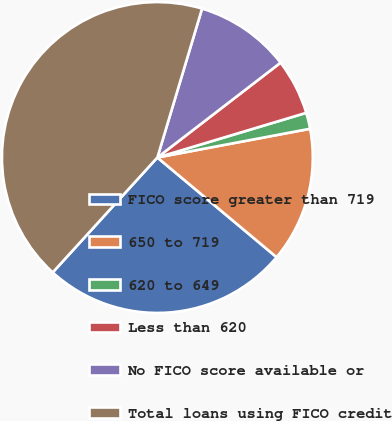Convert chart to OTSL. <chart><loc_0><loc_0><loc_500><loc_500><pie_chart><fcel>FICO score greater than 719<fcel>650 to 719<fcel>620 to 649<fcel>Less than 620<fcel>No FICO score available or<fcel>Total loans using FICO credit<nl><fcel>25.67%<fcel>14.04%<fcel>1.68%<fcel>5.8%<fcel>9.92%<fcel>42.88%<nl></chart> 